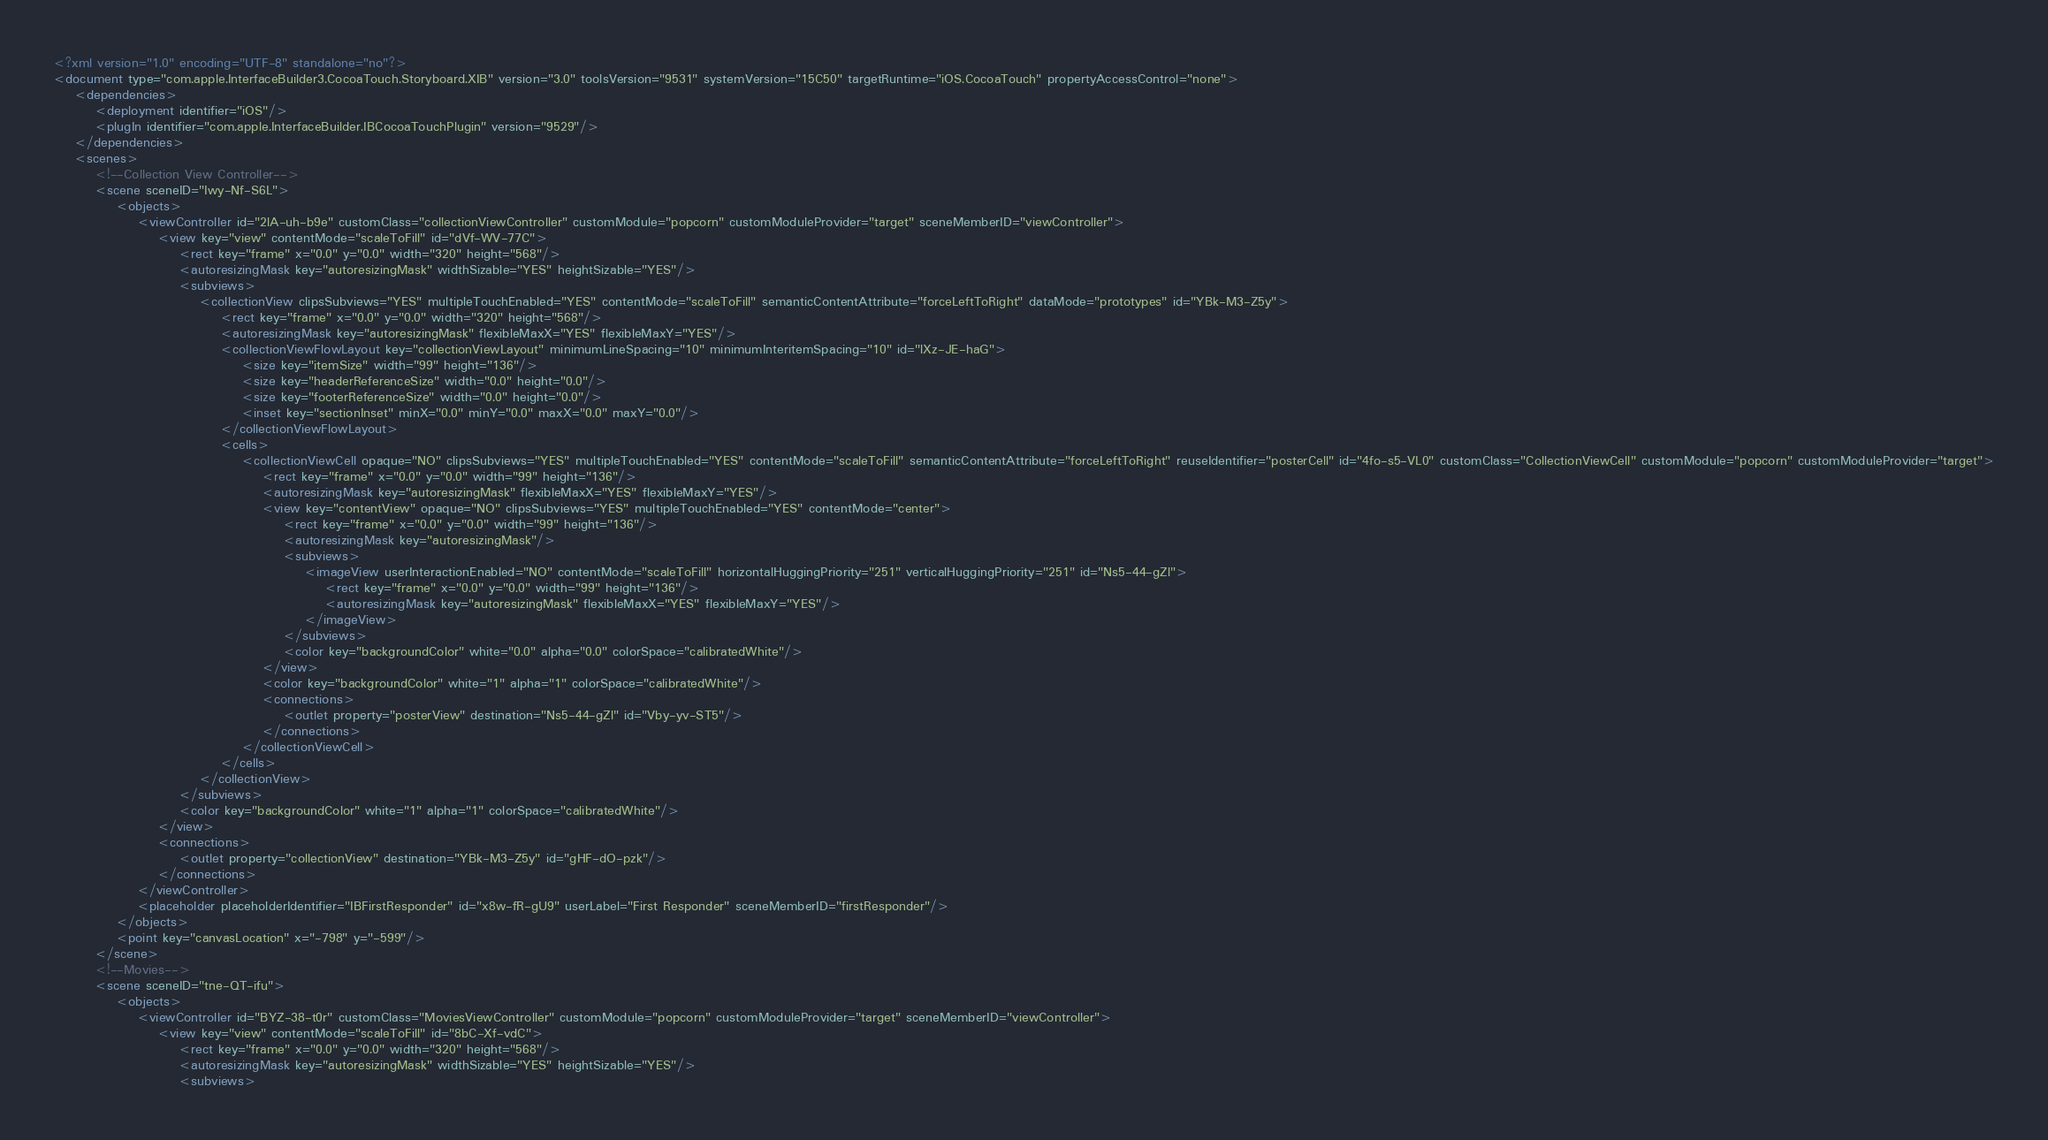<code> <loc_0><loc_0><loc_500><loc_500><_XML_><?xml version="1.0" encoding="UTF-8" standalone="no"?>
<document type="com.apple.InterfaceBuilder3.CocoaTouch.Storyboard.XIB" version="3.0" toolsVersion="9531" systemVersion="15C50" targetRuntime="iOS.CocoaTouch" propertyAccessControl="none">
    <dependencies>
        <deployment identifier="iOS"/>
        <plugIn identifier="com.apple.InterfaceBuilder.IBCocoaTouchPlugin" version="9529"/>
    </dependencies>
    <scenes>
        <!--Collection View Controller-->
        <scene sceneID="Iwy-Nf-S6L">
            <objects>
                <viewController id="2lA-uh-b9e" customClass="collectionViewController" customModule="popcorn" customModuleProvider="target" sceneMemberID="viewController">
                    <view key="view" contentMode="scaleToFill" id="dVf-WV-77C">
                        <rect key="frame" x="0.0" y="0.0" width="320" height="568"/>
                        <autoresizingMask key="autoresizingMask" widthSizable="YES" heightSizable="YES"/>
                        <subviews>
                            <collectionView clipsSubviews="YES" multipleTouchEnabled="YES" contentMode="scaleToFill" semanticContentAttribute="forceLeftToRight" dataMode="prototypes" id="YBk-M3-Z5y">
                                <rect key="frame" x="0.0" y="0.0" width="320" height="568"/>
                                <autoresizingMask key="autoresizingMask" flexibleMaxX="YES" flexibleMaxY="YES"/>
                                <collectionViewFlowLayout key="collectionViewLayout" minimumLineSpacing="10" minimumInteritemSpacing="10" id="lXz-JE-haG">
                                    <size key="itemSize" width="99" height="136"/>
                                    <size key="headerReferenceSize" width="0.0" height="0.0"/>
                                    <size key="footerReferenceSize" width="0.0" height="0.0"/>
                                    <inset key="sectionInset" minX="0.0" minY="0.0" maxX="0.0" maxY="0.0"/>
                                </collectionViewFlowLayout>
                                <cells>
                                    <collectionViewCell opaque="NO" clipsSubviews="YES" multipleTouchEnabled="YES" contentMode="scaleToFill" semanticContentAttribute="forceLeftToRight" reuseIdentifier="posterCell" id="4fo-s5-VL0" customClass="CollectionViewCell" customModule="popcorn" customModuleProvider="target">
                                        <rect key="frame" x="0.0" y="0.0" width="99" height="136"/>
                                        <autoresizingMask key="autoresizingMask" flexibleMaxX="YES" flexibleMaxY="YES"/>
                                        <view key="contentView" opaque="NO" clipsSubviews="YES" multipleTouchEnabled="YES" contentMode="center">
                                            <rect key="frame" x="0.0" y="0.0" width="99" height="136"/>
                                            <autoresizingMask key="autoresizingMask"/>
                                            <subviews>
                                                <imageView userInteractionEnabled="NO" contentMode="scaleToFill" horizontalHuggingPriority="251" verticalHuggingPriority="251" id="Ns5-44-gZl">
                                                    <rect key="frame" x="0.0" y="0.0" width="99" height="136"/>
                                                    <autoresizingMask key="autoresizingMask" flexibleMaxX="YES" flexibleMaxY="YES"/>
                                                </imageView>
                                            </subviews>
                                            <color key="backgroundColor" white="0.0" alpha="0.0" colorSpace="calibratedWhite"/>
                                        </view>
                                        <color key="backgroundColor" white="1" alpha="1" colorSpace="calibratedWhite"/>
                                        <connections>
                                            <outlet property="posterView" destination="Ns5-44-gZl" id="Vby-yv-ST5"/>
                                        </connections>
                                    </collectionViewCell>
                                </cells>
                            </collectionView>
                        </subviews>
                        <color key="backgroundColor" white="1" alpha="1" colorSpace="calibratedWhite"/>
                    </view>
                    <connections>
                        <outlet property="collectionView" destination="YBk-M3-Z5y" id="gHF-dO-pzk"/>
                    </connections>
                </viewController>
                <placeholder placeholderIdentifier="IBFirstResponder" id="x8w-fR-gU9" userLabel="First Responder" sceneMemberID="firstResponder"/>
            </objects>
            <point key="canvasLocation" x="-798" y="-599"/>
        </scene>
        <!--Movies-->
        <scene sceneID="tne-QT-ifu">
            <objects>
                <viewController id="BYZ-38-t0r" customClass="MoviesViewController" customModule="popcorn" customModuleProvider="target" sceneMemberID="viewController">
                    <view key="view" contentMode="scaleToFill" id="8bC-Xf-vdC">
                        <rect key="frame" x="0.0" y="0.0" width="320" height="568"/>
                        <autoresizingMask key="autoresizingMask" widthSizable="YES" heightSizable="YES"/>
                        <subviews></code> 